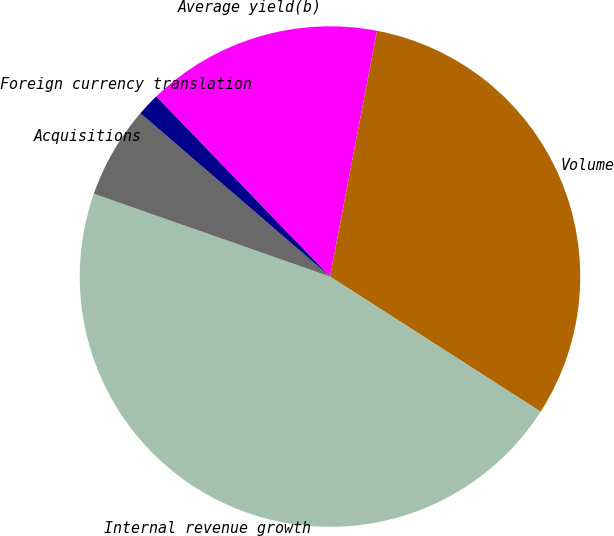<chart> <loc_0><loc_0><loc_500><loc_500><pie_chart><fcel>Average yield(b)<fcel>Volume<fcel>Internal revenue growth<fcel>Acquisitions<fcel>Foreign currency translation<nl><fcel>15.22%<fcel>31.07%<fcel>46.29%<fcel>5.95%<fcel>1.47%<nl></chart> 